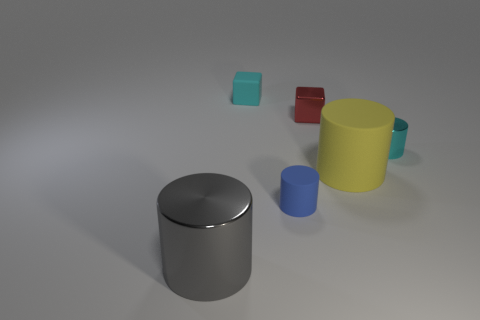Add 3 tiny red objects. How many objects exist? 9 Subtract all blocks. How many objects are left? 4 Add 5 shiny objects. How many shiny objects exist? 8 Subtract 0 green cylinders. How many objects are left? 6 Subtract all small cyan rubber cubes. Subtract all gray metallic things. How many objects are left? 4 Add 4 yellow matte cylinders. How many yellow matte cylinders are left? 5 